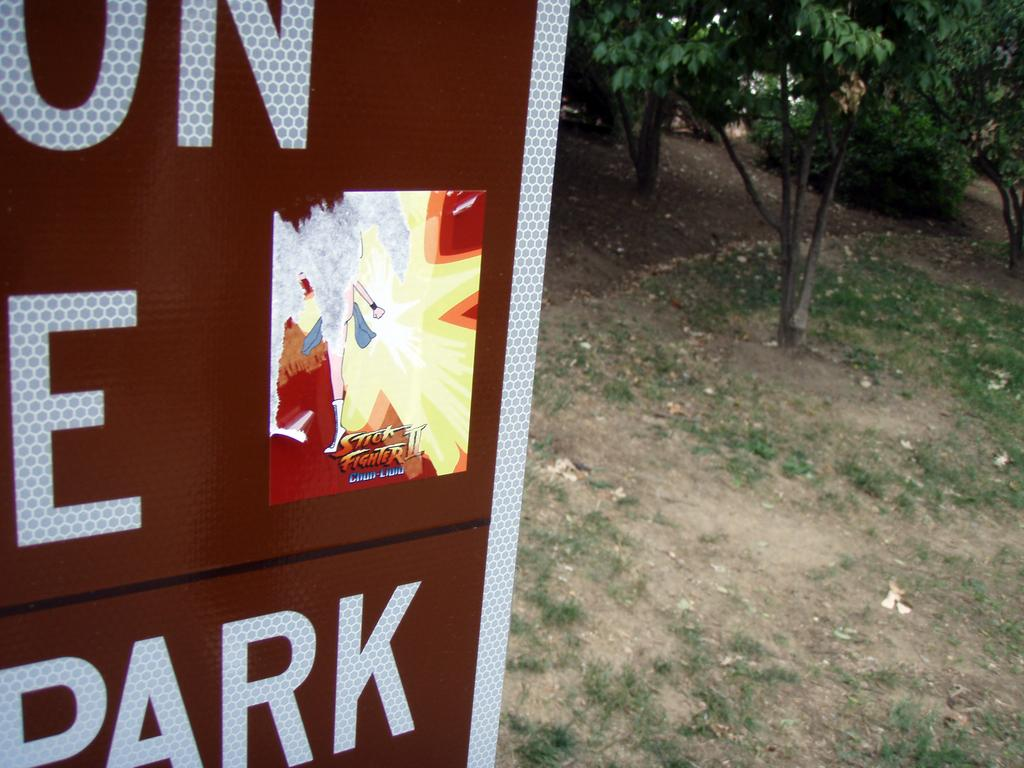What is the main object in the image? There is a signage board in the image. What can be seen on the right side of the image? There are trees, grass, and mud on the right side of the image. What type of bone can be seen sticking out of the mud in the image? There is no bone present in the image; it only features a signage board, trees, grass, and mud. 